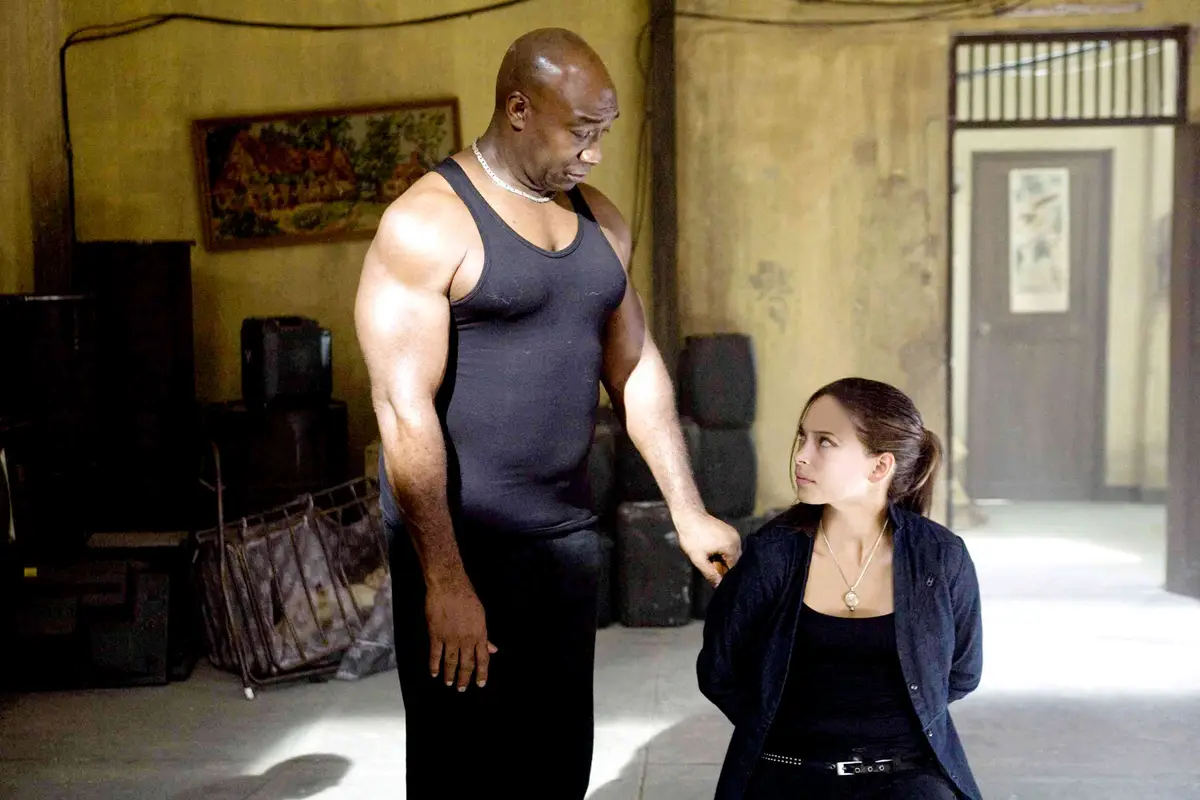What narrative could be inferred from this image? One might infer a narrative revolving around a pivotal moment of mentorship or life lesson being shared between the elder, more experienced character and the younger, possibly inquisitive one. The setting and their expressions suggest a serious, possibly life-altering conversation that involves learning, wisdom sharing, or making tough decisions. This scene might depict either a culmination of past events leading to this moment or an incipient change in the young character's life journey, guided by the older character's advice. 